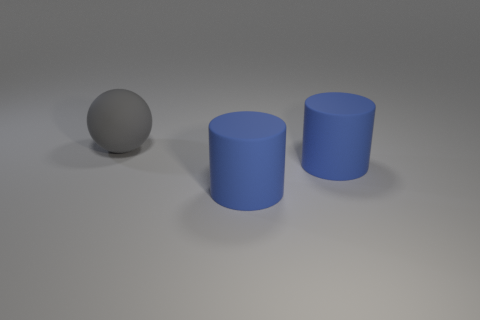Subtract all balls. How many objects are left? 2 Add 1 big balls. How many big balls are left? 2 Add 3 balls. How many balls exist? 4 Add 3 large gray spheres. How many objects exist? 6 Subtract 0 brown balls. How many objects are left? 3 Subtract 1 balls. How many balls are left? 0 Subtract all blue spheres. Subtract all blue cubes. How many spheres are left? 1 Subtract all spheres. Subtract all matte cubes. How many objects are left? 2 